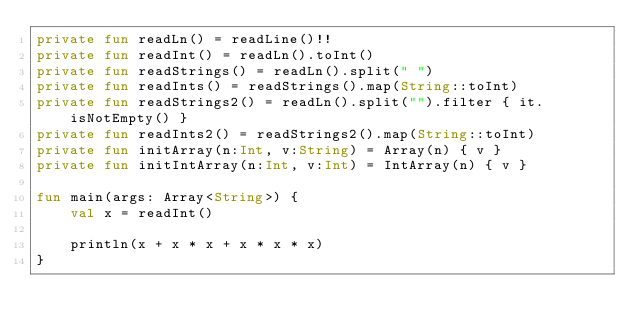<code> <loc_0><loc_0><loc_500><loc_500><_Kotlin_>private fun readLn() = readLine()!!
private fun readInt() = readLn().toInt()
private fun readStrings() = readLn().split(" ")
private fun readInts() = readStrings().map(String::toInt)
private fun readStrings2() = readLn().split("").filter { it.isNotEmpty() }
private fun readInts2() = readStrings2().map(String::toInt)
private fun initArray(n:Int, v:String) = Array(n) { v }
private fun initIntArray(n:Int, v:Int) = IntArray(n) { v }

fun main(args: Array<String>) {
    val x = readInt()

    println(x + x * x + x * x * x)
}</code> 